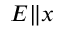Convert formula to latex. <formula><loc_0><loc_0><loc_500><loc_500>E \| x</formula> 